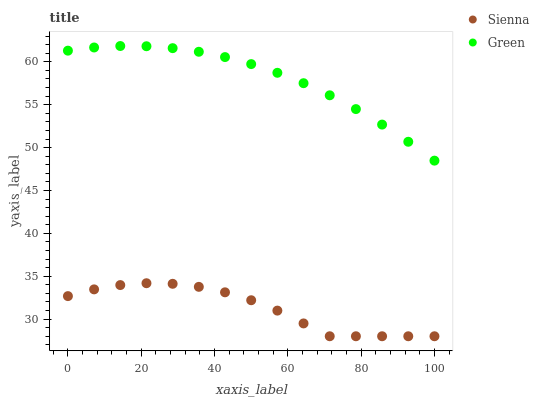Does Sienna have the minimum area under the curve?
Answer yes or no. Yes. Does Green have the maximum area under the curve?
Answer yes or no. Yes. Does Green have the minimum area under the curve?
Answer yes or no. No. Is Green the smoothest?
Answer yes or no. Yes. Is Sienna the roughest?
Answer yes or no. Yes. Is Green the roughest?
Answer yes or no. No. Does Sienna have the lowest value?
Answer yes or no. Yes. Does Green have the lowest value?
Answer yes or no. No. Does Green have the highest value?
Answer yes or no. Yes. Is Sienna less than Green?
Answer yes or no. Yes. Is Green greater than Sienna?
Answer yes or no. Yes. Does Sienna intersect Green?
Answer yes or no. No. 